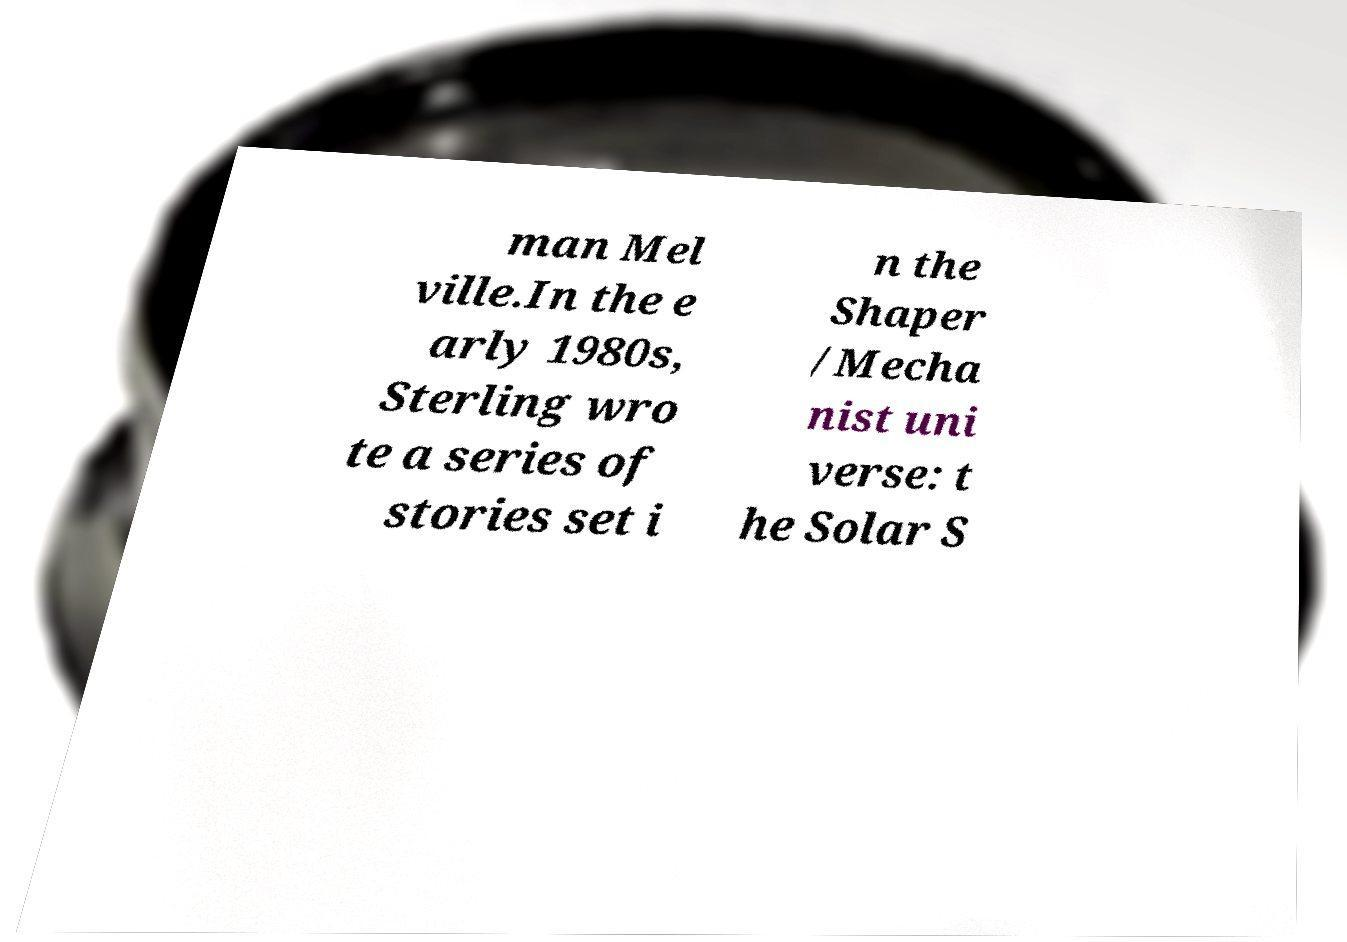Can you read and provide the text displayed in the image?This photo seems to have some interesting text. Can you extract and type it out for me? man Mel ville.In the e arly 1980s, Sterling wro te a series of stories set i n the Shaper /Mecha nist uni verse: t he Solar S 